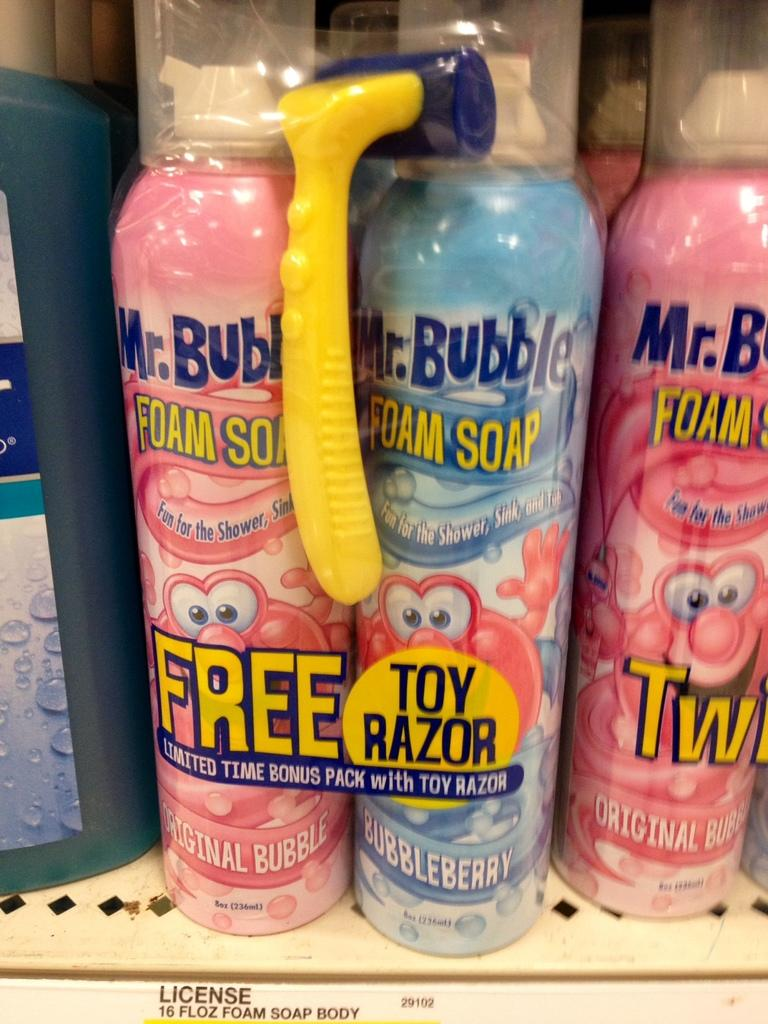<image>
Give a short and clear explanation of the subsequent image. Blue and pink Mr.Bubbles cans being put for sale. 